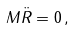Convert formula to latex. <formula><loc_0><loc_0><loc_500><loc_500>M { \ddot { R } } = 0 \, ,</formula> 